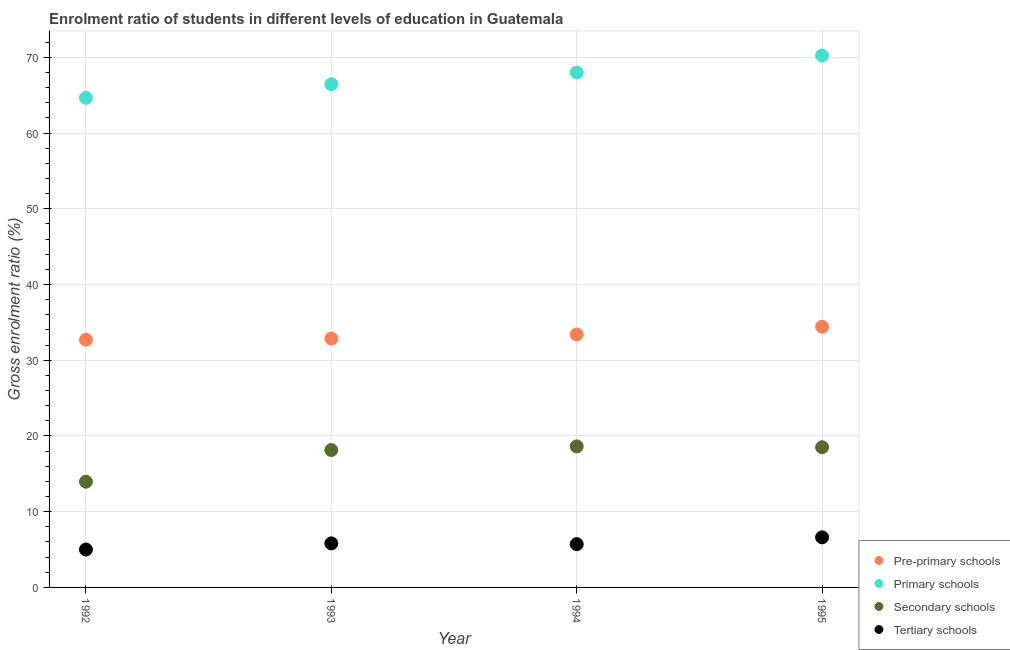Is the number of dotlines equal to the number of legend labels?
Offer a very short reply. Yes. What is the gross enrolment ratio in primary schools in 1995?
Keep it short and to the point. 70.23. Across all years, what is the maximum gross enrolment ratio in pre-primary schools?
Keep it short and to the point. 34.42. Across all years, what is the minimum gross enrolment ratio in primary schools?
Make the answer very short. 64.65. What is the total gross enrolment ratio in primary schools in the graph?
Keep it short and to the point. 269.32. What is the difference between the gross enrolment ratio in tertiary schools in 1992 and that in 1995?
Your answer should be very brief. -1.61. What is the difference between the gross enrolment ratio in pre-primary schools in 1994 and the gross enrolment ratio in tertiary schools in 1995?
Give a very brief answer. 26.79. What is the average gross enrolment ratio in tertiary schools per year?
Keep it short and to the point. 5.79. In the year 1992, what is the difference between the gross enrolment ratio in pre-primary schools and gross enrolment ratio in secondary schools?
Your response must be concise. 18.75. What is the ratio of the gross enrolment ratio in pre-primary schools in 1992 to that in 1994?
Ensure brevity in your answer.  0.98. Is the gross enrolment ratio in primary schools in 1993 less than that in 1995?
Your answer should be very brief. Yes. Is the difference between the gross enrolment ratio in secondary schools in 1992 and 1994 greater than the difference between the gross enrolment ratio in pre-primary schools in 1992 and 1994?
Provide a short and direct response. No. What is the difference between the highest and the second highest gross enrolment ratio in secondary schools?
Ensure brevity in your answer.  0.11. What is the difference between the highest and the lowest gross enrolment ratio in primary schools?
Keep it short and to the point. 5.58. In how many years, is the gross enrolment ratio in pre-primary schools greater than the average gross enrolment ratio in pre-primary schools taken over all years?
Your response must be concise. 2. Is the sum of the gross enrolment ratio in primary schools in 1992 and 1993 greater than the maximum gross enrolment ratio in tertiary schools across all years?
Your answer should be very brief. Yes. Is the gross enrolment ratio in secondary schools strictly less than the gross enrolment ratio in tertiary schools over the years?
Offer a very short reply. No. Are the values on the major ticks of Y-axis written in scientific E-notation?
Offer a very short reply. No. Does the graph contain grids?
Your answer should be very brief. Yes. How many legend labels are there?
Provide a short and direct response. 4. How are the legend labels stacked?
Give a very brief answer. Vertical. What is the title of the graph?
Your response must be concise. Enrolment ratio of students in different levels of education in Guatemala. What is the label or title of the X-axis?
Offer a terse response. Year. What is the Gross enrolment ratio (%) in Pre-primary schools in 1992?
Offer a very short reply. 32.71. What is the Gross enrolment ratio (%) in Primary schools in 1992?
Keep it short and to the point. 64.65. What is the Gross enrolment ratio (%) in Secondary schools in 1992?
Offer a very short reply. 13.96. What is the Gross enrolment ratio (%) of Tertiary schools in 1992?
Make the answer very short. 5. What is the Gross enrolment ratio (%) of Pre-primary schools in 1993?
Ensure brevity in your answer.  32.86. What is the Gross enrolment ratio (%) in Primary schools in 1993?
Keep it short and to the point. 66.44. What is the Gross enrolment ratio (%) in Secondary schools in 1993?
Keep it short and to the point. 18.14. What is the Gross enrolment ratio (%) in Tertiary schools in 1993?
Offer a very short reply. 5.81. What is the Gross enrolment ratio (%) of Pre-primary schools in 1994?
Your answer should be very brief. 33.4. What is the Gross enrolment ratio (%) of Primary schools in 1994?
Provide a short and direct response. 67.99. What is the Gross enrolment ratio (%) in Secondary schools in 1994?
Your response must be concise. 18.62. What is the Gross enrolment ratio (%) of Tertiary schools in 1994?
Your response must be concise. 5.72. What is the Gross enrolment ratio (%) in Pre-primary schools in 1995?
Offer a terse response. 34.42. What is the Gross enrolment ratio (%) in Primary schools in 1995?
Keep it short and to the point. 70.23. What is the Gross enrolment ratio (%) in Secondary schools in 1995?
Offer a very short reply. 18.51. What is the Gross enrolment ratio (%) of Tertiary schools in 1995?
Provide a short and direct response. 6.61. Across all years, what is the maximum Gross enrolment ratio (%) of Pre-primary schools?
Offer a terse response. 34.42. Across all years, what is the maximum Gross enrolment ratio (%) in Primary schools?
Your answer should be very brief. 70.23. Across all years, what is the maximum Gross enrolment ratio (%) of Secondary schools?
Ensure brevity in your answer.  18.62. Across all years, what is the maximum Gross enrolment ratio (%) in Tertiary schools?
Your response must be concise. 6.61. Across all years, what is the minimum Gross enrolment ratio (%) of Pre-primary schools?
Provide a succinct answer. 32.71. Across all years, what is the minimum Gross enrolment ratio (%) of Primary schools?
Your response must be concise. 64.65. Across all years, what is the minimum Gross enrolment ratio (%) in Secondary schools?
Your answer should be compact. 13.96. Across all years, what is the minimum Gross enrolment ratio (%) of Tertiary schools?
Give a very brief answer. 5. What is the total Gross enrolment ratio (%) of Pre-primary schools in the graph?
Your answer should be compact. 133.4. What is the total Gross enrolment ratio (%) in Primary schools in the graph?
Provide a succinct answer. 269.32. What is the total Gross enrolment ratio (%) of Secondary schools in the graph?
Your answer should be compact. 69.24. What is the total Gross enrolment ratio (%) of Tertiary schools in the graph?
Give a very brief answer. 23.15. What is the difference between the Gross enrolment ratio (%) of Pre-primary schools in 1992 and that in 1993?
Give a very brief answer. -0.15. What is the difference between the Gross enrolment ratio (%) of Primary schools in 1992 and that in 1993?
Make the answer very short. -1.79. What is the difference between the Gross enrolment ratio (%) in Secondary schools in 1992 and that in 1993?
Ensure brevity in your answer.  -4.18. What is the difference between the Gross enrolment ratio (%) in Tertiary schools in 1992 and that in 1993?
Give a very brief answer. -0.81. What is the difference between the Gross enrolment ratio (%) of Pre-primary schools in 1992 and that in 1994?
Your answer should be compact. -0.69. What is the difference between the Gross enrolment ratio (%) of Primary schools in 1992 and that in 1994?
Ensure brevity in your answer.  -3.34. What is the difference between the Gross enrolment ratio (%) in Secondary schools in 1992 and that in 1994?
Make the answer very short. -4.66. What is the difference between the Gross enrolment ratio (%) of Tertiary schools in 1992 and that in 1994?
Your answer should be very brief. -0.72. What is the difference between the Gross enrolment ratio (%) in Pre-primary schools in 1992 and that in 1995?
Offer a very short reply. -1.71. What is the difference between the Gross enrolment ratio (%) in Primary schools in 1992 and that in 1995?
Ensure brevity in your answer.  -5.58. What is the difference between the Gross enrolment ratio (%) in Secondary schools in 1992 and that in 1995?
Offer a terse response. -4.55. What is the difference between the Gross enrolment ratio (%) of Tertiary schools in 1992 and that in 1995?
Offer a terse response. -1.61. What is the difference between the Gross enrolment ratio (%) in Pre-primary schools in 1993 and that in 1994?
Offer a very short reply. -0.54. What is the difference between the Gross enrolment ratio (%) in Primary schools in 1993 and that in 1994?
Keep it short and to the point. -1.55. What is the difference between the Gross enrolment ratio (%) in Secondary schools in 1993 and that in 1994?
Ensure brevity in your answer.  -0.48. What is the difference between the Gross enrolment ratio (%) in Tertiary schools in 1993 and that in 1994?
Keep it short and to the point. 0.1. What is the difference between the Gross enrolment ratio (%) in Pre-primary schools in 1993 and that in 1995?
Your answer should be very brief. -1.56. What is the difference between the Gross enrolment ratio (%) in Primary schools in 1993 and that in 1995?
Your answer should be compact. -3.79. What is the difference between the Gross enrolment ratio (%) in Secondary schools in 1993 and that in 1995?
Offer a terse response. -0.37. What is the difference between the Gross enrolment ratio (%) of Tertiary schools in 1993 and that in 1995?
Provide a succinct answer. -0.8. What is the difference between the Gross enrolment ratio (%) in Pre-primary schools in 1994 and that in 1995?
Offer a very short reply. -1.02. What is the difference between the Gross enrolment ratio (%) in Primary schools in 1994 and that in 1995?
Provide a short and direct response. -2.24. What is the difference between the Gross enrolment ratio (%) of Secondary schools in 1994 and that in 1995?
Keep it short and to the point. 0.11. What is the difference between the Gross enrolment ratio (%) of Tertiary schools in 1994 and that in 1995?
Ensure brevity in your answer.  -0.9. What is the difference between the Gross enrolment ratio (%) of Pre-primary schools in 1992 and the Gross enrolment ratio (%) of Primary schools in 1993?
Your response must be concise. -33.73. What is the difference between the Gross enrolment ratio (%) in Pre-primary schools in 1992 and the Gross enrolment ratio (%) in Secondary schools in 1993?
Keep it short and to the point. 14.58. What is the difference between the Gross enrolment ratio (%) in Pre-primary schools in 1992 and the Gross enrolment ratio (%) in Tertiary schools in 1993?
Your answer should be compact. 26.9. What is the difference between the Gross enrolment ratio (%) in Primary schools in 1992 and the Gross enrolment ratio (%) in Secondary schools in 1993?
Provide a succinct answer. 46.51. What is the difference between the Gross enrolment ratio (%) of Primary schools in 1992 and the Gross enrolment ratio (%) of Tertiary schools in 1993?
Your answer should be very brief. 58.84. What is the difference between the Gross enrolment ratio (%) of Secondary schools in 1992 and the Gross enrolment ratio (%) of Tertiary schools in 1993?
Keep it short and to the point. 8.15. What is the difference between the Gross enrolment ratio (%) of Pre-primary schools in 1992 and the Gross enrolment ratio (%) of Primary schools in 1994?
Make the answer very short. -35.28. What is the difference between the Gross enrolment ratio (%) in Pre-primary schools in 1992 and the Gross enrolment ratio (%) in Secondary schools in 1994?
Keep it short and to the point. 14.09. What is the difference between the Gross enrolment ratio (%) of Pre-primary schools in 1992 and the Gross enrolment ratio (%) of Tertiary schools in 1994?
Ensure brevity in your answer.  27. What is the difference between the Gross enrolment ratio (%) of Primary schools in 1992 and the Gross enrolment ratio (%) of Secondary schools in 1994?
Provide a succinct answer. 46.03. What is the difference between the Gross enrolment ratio (%) in Primary schools in 1992 and the Gross enrolment ratio (%) in Tertiary schools in 1994?
Offer a terse response. 58.93. What is the difference between the Gross enrolment ratio (%) of Secondary schools in 1992 and the Gross enrolment ratio (%) of Tertiary schools in 1994?
Make the answer very short. 8.24. What is the difference between the Gross enrolment ratio (%) of Pre-primary schools in 1992 and the Gross enrolment ratio (%) of Primary schools in 1995?
Give a very brief answer. -37.52. What is the difference between the Gross enrolment ratio (%) in Pre-primary schools in 1992 and the Gross enrolment ratio (%) in Secondary schools in 1995?
Offer a very short reply. 14.2. What is the difference between the Gross enrolment ratio (%) of Pre-primary schools in 1992 and the Gross enrolment ratio (%) of Tertiary schools in 1995?
Your answer should be compact. 26.1. What is the difference between the Gross enrolment ratio (%) of Primary schools in 1992 and the Gross enrolment ratio (%) of Secondary schools in 1995?
Make the answer very short. 46.14. What is the difference between the Gross enrolment ratio (%) of Primary schools in 1992 and the Gross enrolment ratio (%) of Tertiary schools in 1995?
Your response must be concise. 58.04. What is the difference between the Gross enrolment ratio (%) of Secondary schools in 1992 and the Gross enrolment ratio (%) of Tertiary schools in 1995?
Provide a short and direct response. 7.35. What is the difference between the Gross enrolment ratio (%) of Pre-primary schools in 1993 and the Gross enrolment ratio (%) of Primary schools in 1994?
Make the answer very short. -35.13. What is the difference between the Gross enrolment ratio (%) in Pre-primary schools in 1993 and the Gross enrolment ratio (%) in Secondary schools in 1994?
Your answer should be very brief. 14.24. What is the difference between the Gross enrolment ratio (%) of Pre-primary schools in 1993 and the Gross enrolment ratio (%) of Tertiary schools in 1994?
Make the answer very short. 27.14. What is the difference between the Gross enrolment ratio (%) of Primary schools in 1993 and the Gross enrolment ratio (%) of Secondary schools in 1994?
Make the answer very short. 47.82. What is the difference between the Gross enrolment ratio (%) of Primary schools in 1993 and the Gross enrolment ratio (%) of Tertiary schools in 1994?
Your response must be concise. 60.73. What is the difference between the Gross enrolment ratio (%) of Secondary schools in 1993 and the Gross enrolment ratio (%) of Tertiary schools in 1994?
Provide a succinct answer. 12.42. What is the difference between the Gross enrolment ratio (%) of Pre-primary schools in 1993 and the Gross enrolment ratio (%) of Primary schools in 1995?
Your answer should be very brief. -37.37. What is the difference between the Gross enrolment ratio (%) in Pre-primary schools in 1993 and the Gross enrolment ratio (%) in Secondary schools in 1995?
Give a very brief answer. 14.35. What is the difference between the Gross enrolment ratio (%) of Pre-primary schools in 1993 and the Gross enrolment ratio (%) of Tertiary schools in 1995?
Your response must be concise. 26.25. What is the difference between the Gross enrolment ratio (%) in Primary schools in 1993 and the Gross enrolment ratio (%) in Secondary schools in 1995?
Keep it short and to the point. 47.93. What is the difference between the Gross enrolment ratio (%) in Primary schools in 1993 and the Gross enrolment ratio (%) in Tertiary schools in 1995?
Keep it short and to the point. 59.83. What is the difference between the Gross enrolment ratio (%) in Secondary schools in 1993 and the Gross enrolment ratio (%) in Tertiary schools in 1995?
Your answer should be very brief. 11.53. What is the difference between the Gross enrolment ratio (%) in Pre-primary schools in 1994 and the Gross enrolment ratio (%) in Primary schools in 1995?
Provide a short and direct response. -36.83. What is the difference between the Gross enrolment ratio (%) in Pre-primary schools in 1994 and the Gross enrolment ratio (%) in Secondary schools in 1995?
Offer a very short reply. 14.89. What is the difference between the Gross enrolment ratio (%) of Pre-primary schools in 1994 and the Gross enrolment ratio (%) of Tertiary schools in 1995?
Provide a succinct answer. 26.79. What is the difference between the Gross enrolment ratio (%) of Primary schools in 1994 and the Gross enrolment ratio (%) of Secondary schools in 1995?
Ensure brevity in your answer.  49.48. What is the difference between the Gross enrolment ratio (%) in Primary schools in 1994 and the Gross enrolment ratio (%) in Tertiary schools in 1995?
Your answer should be very brief. 61.38. What is the difference between the Gross enrolment ratio (%) of Secondary schools in 1994 and the Gross enrolment ratio (%) of Tertiary schools in 1995?
Ensure brevity in your answer.  12.01. What is the average Gross enrolment ratio (%) in Pre-primary schools per year?
Provide a short and direct response. 33.35. What is the average Gross enrolment ratio (%) in Primary schools per year?
Your response must be concise. 67.33. What is the average Gross enrolment ratio (%) in Secondary schools per year?
Provide a succinct answer. 17.31. What is the average Gross enrolment ratio (%) in Tertiary schools per year?
Offer a terse response. 5.79. In the year 1992, what is the difference between the Gross enrolment ratio (%) in Pre-primary schools and Gross enrolment ratio (%) in Primary schools?
Offer a very short reply. -31.94. In the year 1992, what is the difference between the Gross enrolment ratio (%) in Pre-primary schools and Gross enrolment ratio (%) in Secondary schools?
Offer a terse response. 18.75. In the year 1992, what is the difference between the Gross enrolment ratio (%) in Pre-primary schools and Gross enrolment ratio (%) in Tertiary schools?
Make the answer very short. 27.71. In the year 1992, what is the difference between the Gross enrolment ratio (%) in Primary schools and Gross enrolment ratio (%) in Secondary schools?
Give a very brief answer. 50.69. In the year 1992, what is the difference between the Gross enrolment ratio (%) of Primary schools and Gross enrolment ratio (%) of Tertiary schools?
Provide a short and direct response. 59.65. In the year 1992, what is the difference between the Gross enrolment ratio (%) in Secondary schools and Gross enrolment ratio (%) in Tertiary schools?
Your answer should be very brief. 8.96. In the year 1993, what is the difference between the Gross enrolment ratio (%) of Pre-primary schools and Gross enrolment ratio (%) of Primary schools?
Offer a very short reply. -33.58. In the year 1993, what is the difference between the Gross enrolment ratio (%) in Pre-primary schools and Gross enrolment ratio (%) in Secondary schools?
Your answer should be compact. 14.72. In the year 1993, what is the difference between the Gross enrolment ratio (%) of Pre-primary schools and Gross enrolment ratio (%) of Tertiary schools?
Keep it short and to the point. 27.05. In the year 1993, what is the difference between the Gross enrolment ratio (%) of Primary schools and Gross enrolment ratio (%) of Secondary schools?
Give a very brief answer. 48.3. In the year 1993, what is the difference between the Gross enrolment ratio (%) of Primary schools and Gross enrolment ratio (%) of Tertiary schools?
Provide a succinct answer. 60.63. In the year 1993, what is the difference between the Gross enrolment ratio (%) in Secondary schools and Gross enrolment ratio (%) in Tertiary schools?
Your answer should be very brief. 12.33. In the year 1994, what is the difference between the Gross enrolment ratio (%) in Pre-primary schools and Gross enrolment ratio (%) in Primary schools?
Your answer should be very brief. -34.59. In the year 1994, what is the difference between the Gross enrolment ratio (%) in Pre-primary schools and Gross enrolment ratio (%) in Secondary schools?
Ensure brevity in your answer.  14.78. In the year 1994, what is the difference between the Gross enrolment ratio (%) of Pre-primary schools and Gross enrolment ratio (%) of Tertiary schools?
Keep it short and to the point. 27.68. In the year 1994, what is the difference between the Gross enrolment ratio (%) in Primary schools and Gross enrolment ratio (%) in Secondary schools?
Give a very brief answer. 49.37. In the year 1994, what is the difference between the Gross enrolment ratio (%) of Primary schools and Gross enrolment ratio (%) of Tertiary schools?
Your response must be concise. 62.27. In the year 1994, what is the difference between the Gross enrolment ratio (%) in Secondary schools and Gross enrolment ratio (%) in Tertiary schools?
Ensure brevity in your answer.  12.91. In the year 1995, what is the difference between the Gross enrolment ratio (%) in Pre-primary schools and Gross enrolment ratio (%) in Primary schools?
Give a very brief answer. -35.81. In the year 1995, what is the difference between the Gross enrolment ratio (%) of Pre-primary schools and Gross enrolment ratio (%) of Secondary schools?
Your response must be concise. 15.91. In the year 1995, what is the difference between the Gross enrolment ratio (%) of Pre-primary schools and Gross enrolment ratio (%) of Tertiary schools?
Your response must be concise. 27.81. In the year 1995, what is the difference between the Gross enrolment ratio (%) of Primary schools and Gross enrolment ratio (%) of Secondary schools?
Give a very brief answer. 51.72. In the year 1995, what is the difference between the Gross enrolment ratio (%) in Primary schools and Gross enrolment ratio (%) in Tertiary schools?
Ensure brevity in your answer.  63.62. In the year 1995, what is the difference between the Gross enrolment ratio (%) in Secondary schools and Gross enrolment ratio (%) in Tertiary schools?
Provide a short and direct response. 11.9. What is the ratio of the Gross enrolment ratio (%) of Primary schools in 1992 to that in 1993?
Give a very brief answer. 0.97. What is the ratio of the Gross enrolment ratio (%) of Secondary schools in 1992 to that in 1993?
Provide a succinct answer. 0.77. What is the ratio of the Gross enrolment ratio (%) in Tertiary schools in 1992 to that in 1993?
Ensure brevity in your answer.  0.86. What is the ratio of the Gross enrolment ratio (%) in Pre-primary schools in 1992 to that in 1994?
Your response must be concise. 0.98. What is the ratio of the Gross enrolment ratio (%) of Primary schools in 1992 to that in 1994?
Provide a succinct answer. 0.95. What is the ratio of the Gross enrolment ratio (%) in Secondary schools in 1992 to that in 1994?
Make the answer very short. 0.75. What is the ratio of the Gross enrolment ratio (%) of Tertiary schools in 1992 to that in 1994?
Keep it short and to the point. 0.87. What is the ratio of the Gross enrolment ratio (%) of Pre-primary schools in 1992 to that in 1995?
Your answer should be compact. 0.95. What is the ratio of the Gross enrolment ratio (%) of Primary schools in 1992 to that in 1995?
Your response must be concise. 0.92. What is the ratio of the Gross enrolment ratio (%) of Secondary schools in 1992 to that in 1995?
Make the answer very short. 0.75. What is the ratio of the Gross enrolment ratio (%) of Tertiary schools in 1992 to that in 1995?
Keep it short and to the point. 0.76. What is the ratio of the Gross enrolment ratio (%) in Pre-primary schools in 1993 to that in 1994?
Keep it short and to the point. 0.98. What is the ratio of the Gross enrolment ratio (%) of Primary schools in 1993 to that in 1994?
Offer a very short reply. 0.98. What is the ratio of the Gross enrolment ratio (%) in Tertiary schools in 1993 to that in 1994?
Ensure brevity in your answer.  1.02. What is the ratio of the Gross enrolment ratio (%) in Pre-primary schools in 1993 to that in 1995?
Your answer should be very brief. 0.95. What is the ratio of the Gross enrolment ratio (%) in Primary schools in 1993 to that in 1995?
Keep it short and to the point. 0.95. What is the ratio of the Gross enrolment ratio (%) in Secondary schools in 1993 to that in 1995?
Ensure brevity in your answer.  0.98. What is the ratio of the Gross enrolment ratio (%) of Tertiary schools in 1993 to that in 1995?
Give a very brief answer. 0.88. What is the ratio of the Gross enrolment ratio (%) of Pre-primary schools in 1994 to that in 1995?
Give a very brief answer. 0.97. What is the ratio of the Gross enrolment ratio (%) of Primary schools in 1994 to that in 1995?
Your response must be concise. 0.97. What is the ratio of the Gross enrolment ratio (%) of Tertiary schools in 1994 to that in 1995?
Your answer should be very brief. 0.86. What is the difference between the highest and the second highest Gross enrolment ratio (%) in Pre-primary schools?
Offer a terse response. 1.02. What is the difference between the highest and the second highest Gross enrolment ratio (%) in Primary schools?
Make the answer very short. 2.24. What is the difference between the highest and the second highest Gross enrolment ratio (%) of Secondary schools?
Provide a succinct answer. 0.11. What is the difference between the highest and the second highest Gross enrolment ratio (%) of Tertiary schools?
Your answer should be compact. 0.8. What is the difference between the highest and the lowest Gross enrolment ratio (%) in Pre-primary schools?
Make the answer very short. 1.71. What is the difference between the highest and the lowest Gross enrolment ratio (%) of Primary schools?
Your answer should be very brief. 5.58. What is the difference between the highest and the lowest Gross enrolment ratio (%) in Secondary schools?
Keep it short and to the point. 4.66. What is the difference between the highest and the lowest Gross enrolment ratio (%) of Tertiary schools?
Offer a very short reply. 1.61. 